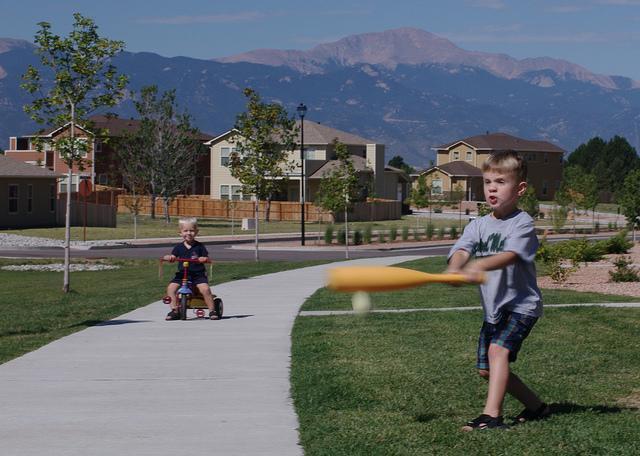How many people in the shot?
Give a very brief answer. 2. How many people can you see?
Give a very brief answer. 2. 